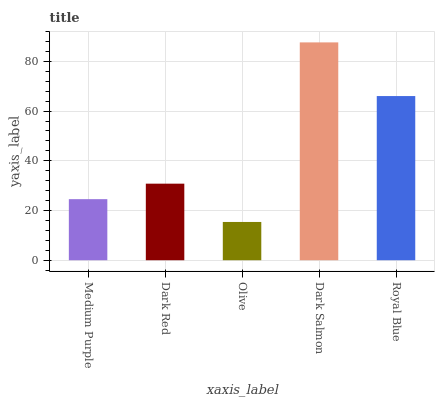Is Olive the minimum?
Answer yes or no. Yes. Is Dark Salmon the maximum?
Answer yes or no. Yes. Is Dark Red the minimum?
Answer yes or no. No. Is Dark Red the maximum?
Answer yes or no. No. Is Dark Red greater than Medium Purple?
Answer yes or no. Yes. Is Medium Purple less than Dark Red?
Answer yes or no. Yes. Is Medium Purple greater than Dark Red?
Answer yes or no. No. Is Dark Red less than Medium Purple?
Answer yes or no. No. Is Dark Red the high median?
Answer yes or no. Yes. Is Dark Red the low median?
Answer yes or no. Yes. Is Medium Purple the high median?
Answer yes or no. No. Is Medium Purple the low median?
Answer yes or no. No. 